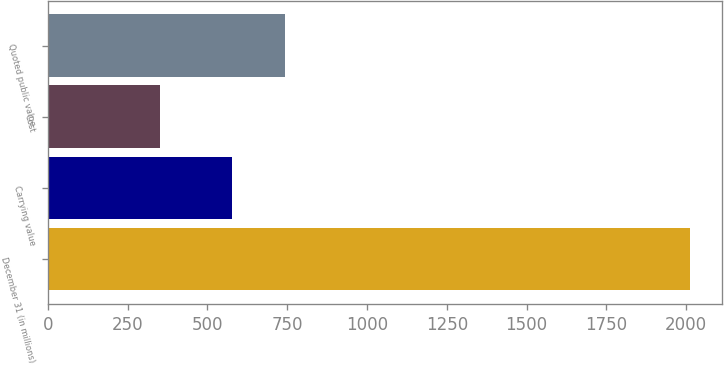<chart> <loc_0><loc_0><loc_500><loc_500><bar_chart><fcel>December 31 (in millions)<fcel>Carrying value<fcel>Cost<fcel>Quoted public value<nl><fcel>2012<fcel>578<fcel>350<fcel>744.2<nl></chart> 